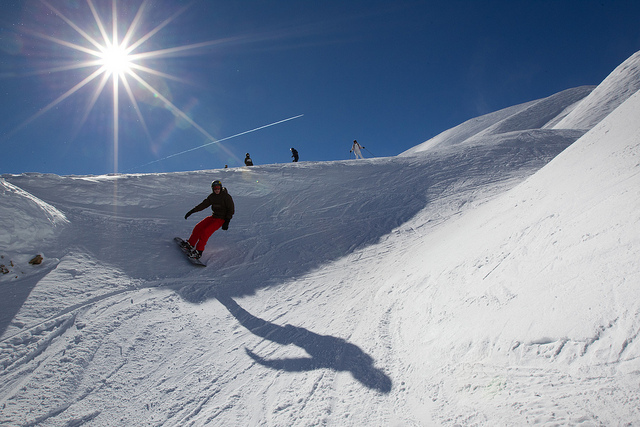How many snowboarders are in the picture? There is one snowboarder captured mid-action on the slope, exhibiting both the thrill of the sport and the serene, wintry landscape that surrounds them. 